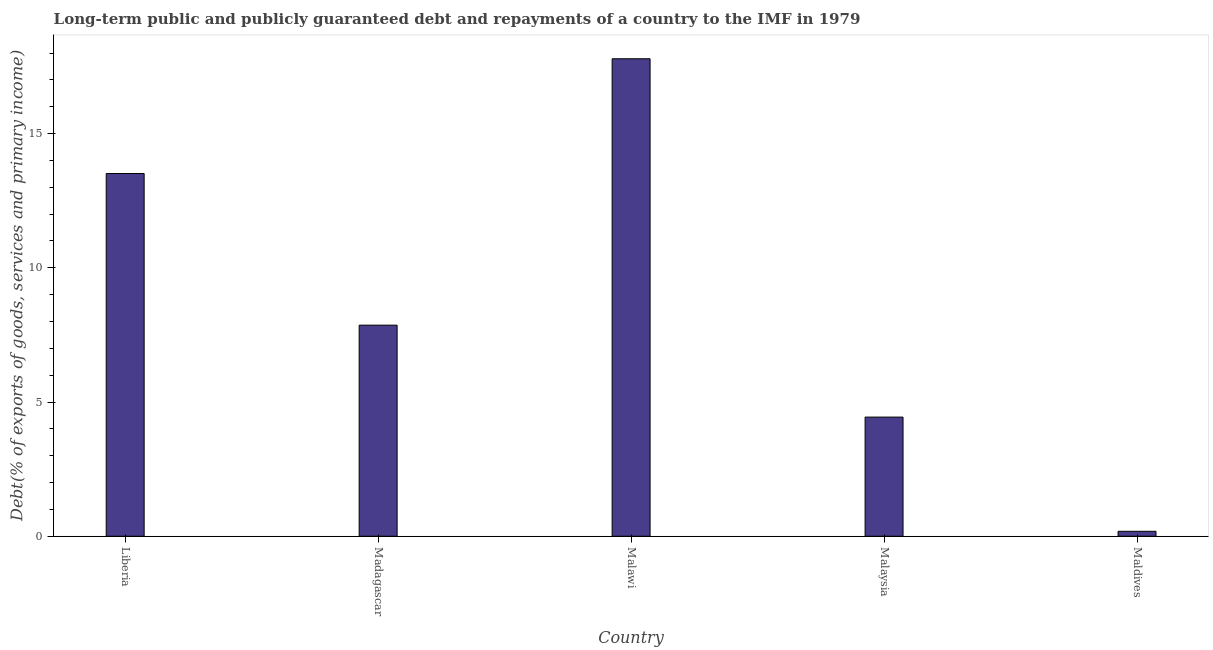Does the graph contain any zero values?
Make the answer very short. No. What is the title of the graph?
Provide a short and direct response. Long-term public and publicly guaranteed debt and repayments of a country to the IMF in 1979. What is the label or title of the Y-axis?
Keep it short and to the point. Debt(% of exports of goods, services and primary income). What is the debt service in Madagascar?
Your response must be concise. 7.86. Across all countries, what is the maximum debt service?
Keep it short and to the point. 17.79. Across all countries, what is the minimum debt service?
Provide a short and direct response. 0.18. In which country was the debt service maximum?
Provide a short and direct response. Malawi. In which country was the debt service minimum?
Ensure brevity in your answer.  Maldives. What is the sum of the debt service?
Your response must be concise. 43.78. What is the difference between the debt service in Madagascar and Malaysia?
Ensure brevity in your answer.  3.42. What is the average debt service per country?
Make the answer very short. 8.76. What is the median debt service?
Ensure brevity in your answer.  7.86. In how many countries, is the debt service greater than 2 %?
Your answer should be very brief. 4. What is the ratio of the debt service in Liberia to that in Madagascar?
Keep it short and to the point. 1.72. Is the debt service in Liberia less than that in Madagascar?
Ensure brevity in your answer.  No. Is the difference between the debt service in Liberia and Maldives greater than the difference between any two countries?
Ensure brevity in your answer.  No. What is the difference between the highest and the second highest debt service?
Ensure brevity in your answer.  4.28. In how many countries, is the debt service greater than the average debt service taken over all countries?
Provide a succinct answer. 2. How many bars are there?
Make the answer very short. 5. How many countries are there in the graph?
Keep it short and to the point. 5. Are the values on the major ticks of Y-axis written in scientific E-notation?
Your response must be concise. No. What is the Debt(% of exports of goods, services and primary income) in Liberia?
Your answer should be compact. 13.51. What is the Debt(% of exports of goods, services and primary income) of Madagascar?
Provide a succinct answer. 7.86. What is the Debt(% of exports of goods, services and primary income) in Malawi?
Ensure brevity in your answer.  17.79. What is the Debt(% of exports of goods, services and primary income) of Malaysia?
Offer a terse response. 4.44. What is the Debt(% of exports of goods, services and primary income) in Maldives?
Make the answer very short. 0.18. What is the difference between the Debt(% of exports of goods, services and primary income) in Liberia and Madagascar?
Ensure brevity in your answer.  5.65. What is the difference between the Debt(% of exports of goods, services and primary income) in Liberia and Malawi?
Offer a very short reply. -4.28. What is the difference between the Debt(% of exports of goods, services and primary income) in Liberia and Malaysia?
Provide a short and direct response. 9.07. What is the difference between the Debt(% of exports of goods, services and primary income) in Liberia and Maldives?
Your answer should be compact. 13.33. What is the difference between the Debt(% of exports of goods, services and primary income) in Madagascar and Malawi?
Offer a very short reply. -9.92. What is the difference between the Debt(% of exports of goods, services and primary income) in Madagascar and Malaysia?
Offer a terse response. 3.42. What is the difference between the Debt(% of exports of goods, services and primary income) in Madagascar and Maldives?
Offer a terse response. 7.68. What is the difference between the Debt(% of exports of goods, services and primary income) in Malawi and Malaysia?
Ensure brevity in your answer.  13.35. What is the difference between the Debt(% of exports of goods, services and primary income) in Malawi and Maldives?
Give a very brief answer. 17.6. What is the difference between the Debt(% of exports of goods, services and primary income) in Malaysia and Maldives?
Make the answer very short. 4.25. What is the ratio of the Debt(% of exports of goods, services and primary income) in Liberia to that in Madagascar?
Your answer should be compact. 1.72. What is the ratio of the Debt(% of exports of goods, services and primary income) in Liberia to that in Malawi?
Make the answer very short. 0.76. What is the ratio of the Debt(% of exports of goods, services and primary income) in Liberia to that in Malaysia?
Offer a very short reply. 3.04. What is the ratio of the Debt(% of exports of goods, services and primary income) in Liberia to that in Maldives?
Ensure brevity in your answer.  73.35. What is the ratio of the Debt(% of exports of goods, services and primary income) in Madagascar to that in Malawi?
Your answer should be compact. 0.44. What is the ratio of the Debt(% of exports of goods, services and primary income) in Madagascar to that in Malaysia?
Give a very brief answer. 1.77. What is the ratio of the Debt(% of exports of goods, services and primary income) in Madagascar to that in Maldives?
Your response must be concise. 42.69. What is the ratio of the Debt(% of exports of goods, services and primary income) in Malawi to that in Malaysia?
Keep it short and to the point. 4.01. What is the ratio of the Debt(% of exports of goods, services and primary income) in Malawi to that in Maldives?
Offer a very short reply. 96.56. What is the ratio of the Debt(% of exports of goods, services and primary income) in Malaysia to that in Maldives?
Offer a terse response. 24.09. 